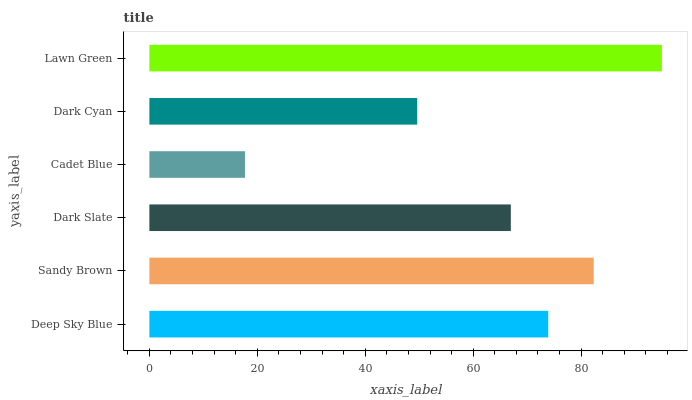Is Cadet Blue the minimum?
Answer yes or no. Yes. Is Lawn Green the maximum?
Answer yes or no. Yes. Is Sandy Brown the minimum?
Answer yes or no. No. Is Sandy Brown the maximum?
Answer yes or no. No. Is Sandy Brown greater than Deep Sky Blue?
Answer yes or no. Yes. Is Deep Sky Blue less than Sandy Brown?
Answer yes or no. Yes. Is Deep Sky Blue greater than Sandy Brown?
Answer yes or no. No. Is Sandy Brown less than Deep Sky Blue?
Answer yes or no. No. Is Deep Sky Blue the high median?
Answer yes or no. Yes. Is Dark Slate the low median?
Answer yes or no. Yes. Is Sandy Brown the high median?
Answer yes or no. No. Is Lawn Green the low median?
Answer yes or no. No. 